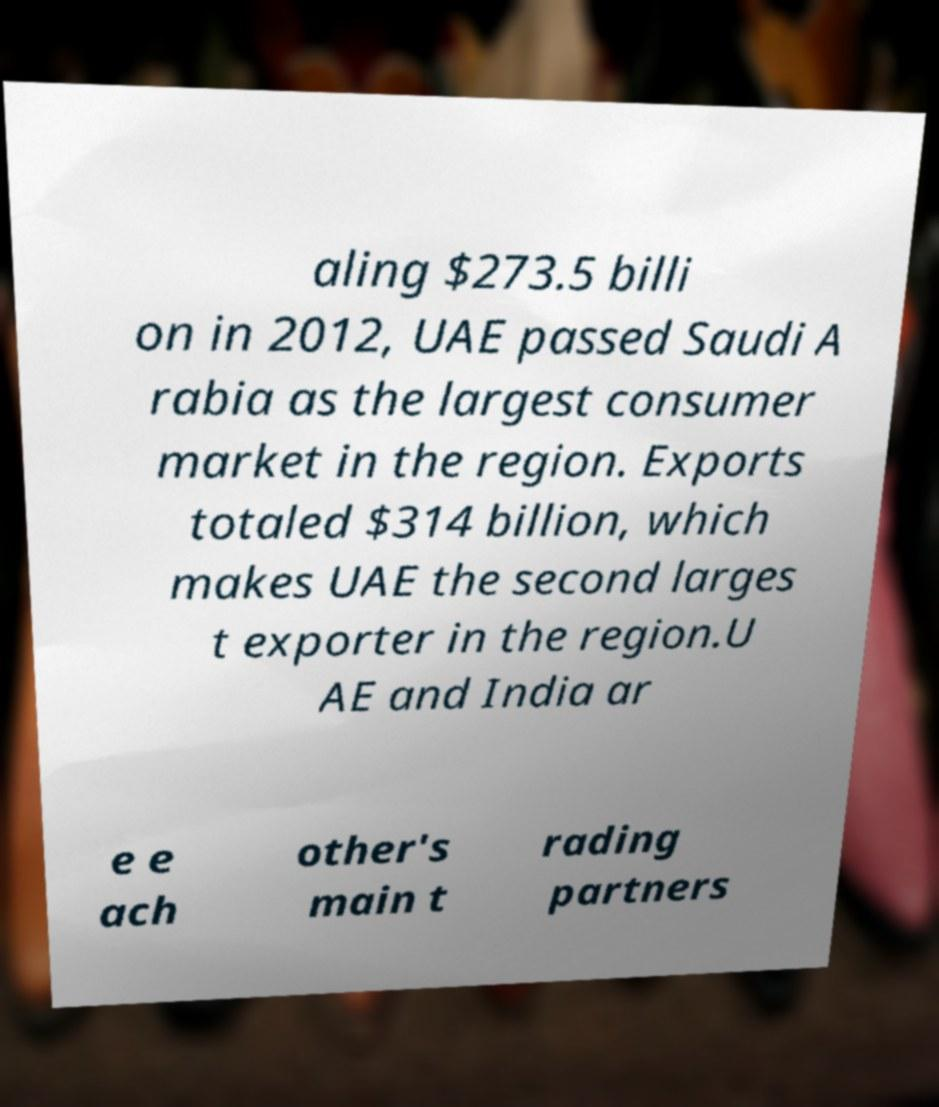Please read and relay the text visible in this image. What does it say? aling $273.5 billi on in 2012, UAE passed Saudi A rabia as the largest consumer market in the region. Exports totaled $314 billion, which makes UAE the second larges t exporter in the region.U AE and India ar e e ach other's main t rading partners 